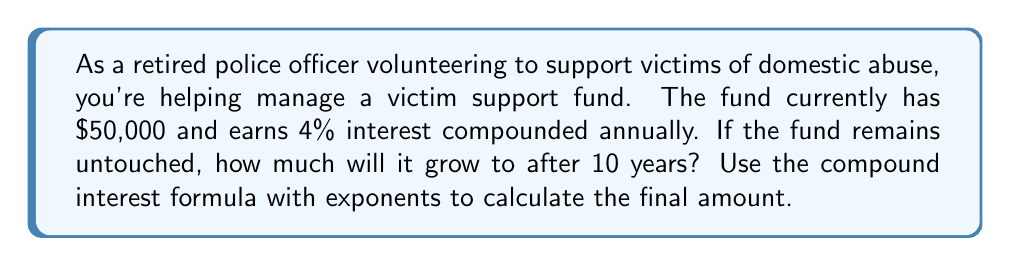Could you help me with this problem? To solve this problem, we'll use the compound interest formula:

$$A = P(1 + r)^n$$

Where:
$A$ = Final amount
$P$ = Principal (initial investment)
$r$ = Annual interest rate (in decimal form)
$n$ = Number of years

Given:
$P = \$50,000$
$r = 4\% = 0.04$
$n = 10$ years

Let's substitute these values into the formula:

$$A = 50,000(1 + 0.04)^{10}$$

Now, let's solve step-by-step:

1) First, calculate $(1 + 0.04)$:
   $1 + 0.04 = 1.04$

2) Now, we have:
   $$A = 50,000(1.04)^{10}$$

3) Calculate $(1.04)^{10}$:
   $(1.04)^{10} \approx 1.4802$

4) Finally, multiply:
   $$A = 50,000 \times 1.4802 = 74,010$$

Therefore, after 10 years, the victim support fund will grow to approximately $74,010.
Answer: $74,010 